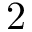<formula> <loc_0><loc_0><loc_500><loc_500>2</formula> 